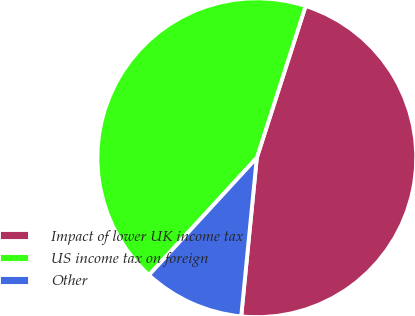Convert chart. <chart><loc_0><loc_0><loc_500><loc_500><pie_chart><fcel>Impact of lower UK income tax<fcel>US income tax on foreign<fcel>Other<nl><fcel>46.61%<fcel>43.12%<fcel>10.27%<nl></chart> 